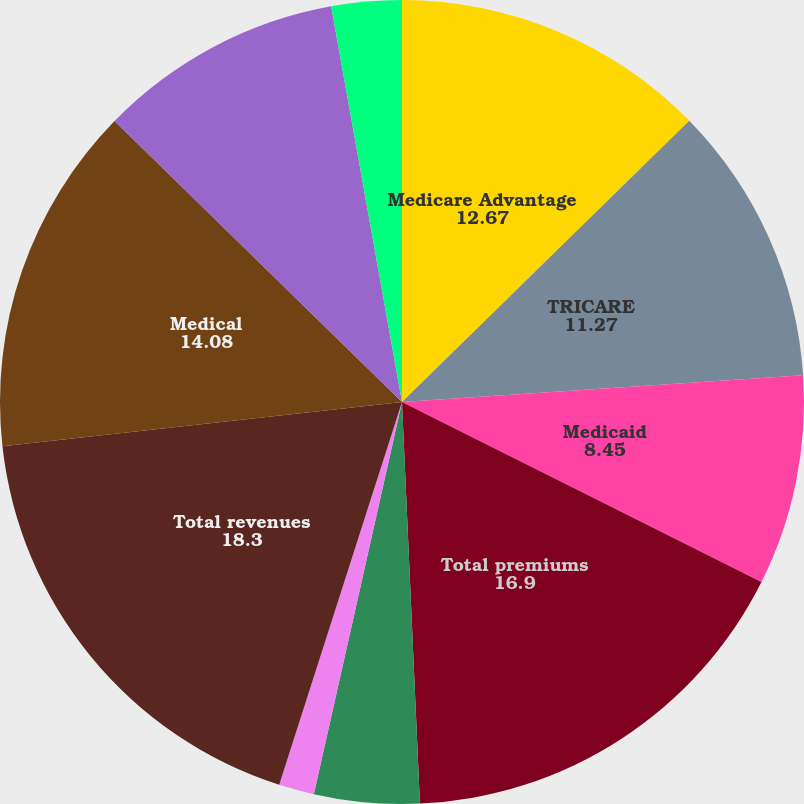Convert chart to OTSL. <chart><loc_0><loc_0><loc_500><loc_500><pie_chart><fcel>Medicare Advantage<fcel>TRICARE<fcel>Medicaid<fcel>Total premiums<fcel>Administrative services fees<fcel>Investment and other income<fcel>Total revenues<fcel>Medical<fcel>Selling general and<fcel>Depreciation and amortization<nl><fcel>12.67%<fcel>11.27%<fcel>8.45%<fcel>16.9%<fcel>4.23%<fcel>1.42%<fcel>18.3%<fcel>14.08%<fcel>9.86%<fcel>2.82%<nl></chart> 